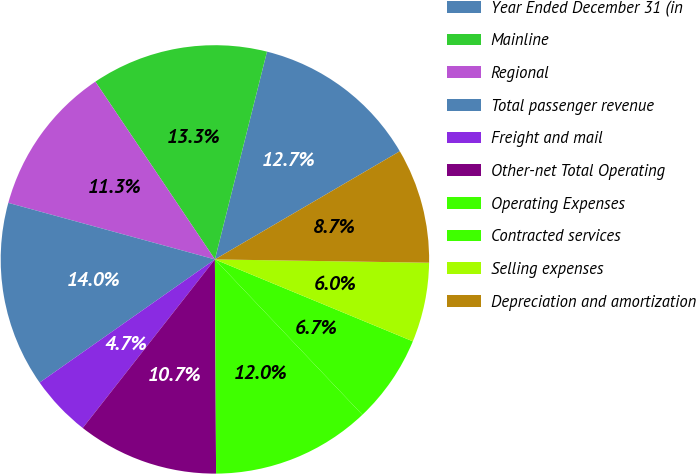<chart> <loc_0><loc_0><loc_500><loc_500><pie_chart><fcel>Year Ended December 31 (in<fcel>Mainline<fcel>Regional<fcel>Total passenger revenue<fcel>Freight and mail<fcel>Other-net Total Operating<fcel>Operating Expenses<fcel>Contracted services<fcel>Selling expenses<fcel>Depreciation and amortization<nl><fcel>12.67%<fcel>13.33%<fcel>11.33%<fcel>14.0%<fcel>4.67%<fcel>10.67%<fcel>12.0%<fcel>6.67%<fcel>6.0%<fcel>8.67%<nl></chart> 